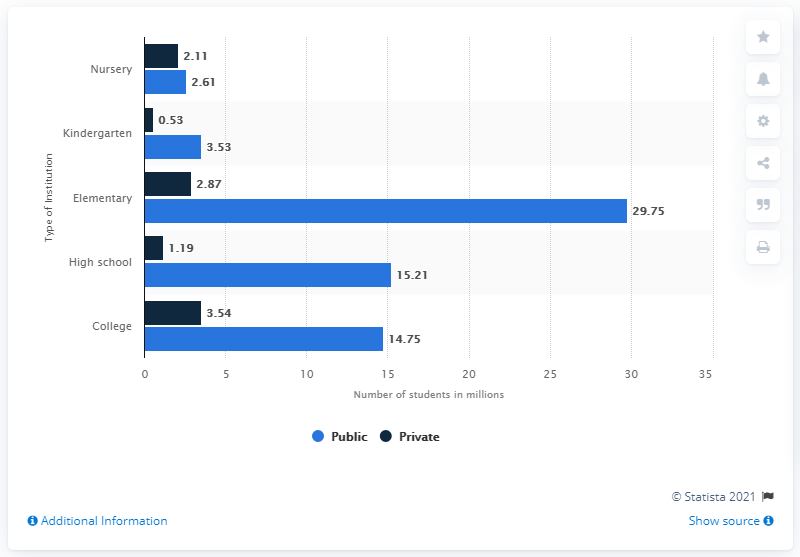Identify some key points in this picture. The type of institution that had the highest number of students was elementary schools. In 2019, the number of students enrolled in private high schools was 1.19 million. In the year 2019, there were 15.21 students enrolled in public high schools. The difference between students in college and nursery is 13.57. 